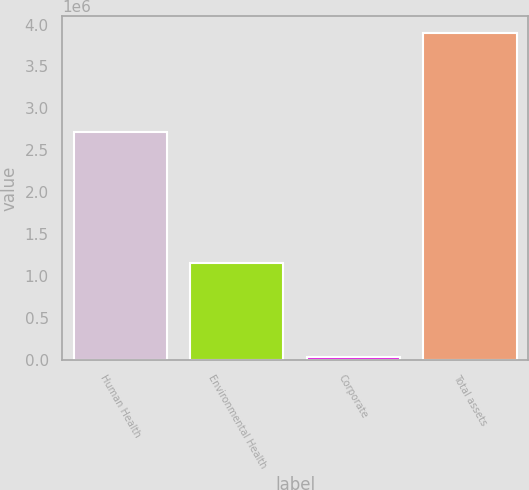Convert chart to OTSL. <chart><loc_0><loc_0><loc_500><loc_500><bar_chart><fcel>Human Health<fcel>Environmental Health<fcel>Corporate<fcel>Total assets<nl><fcel>2.71437e+06<fcel>1.15344e+06<fcel>33952<fcel>3.90176e+06<nl></chart> 